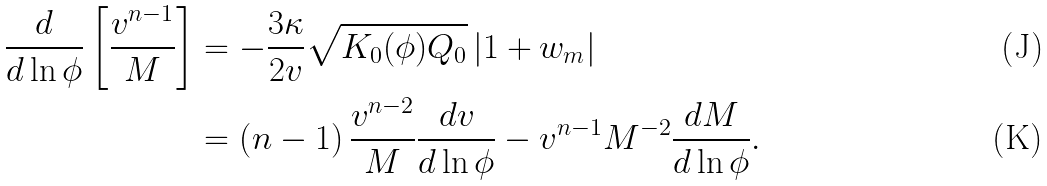<formula> <loc_0><loc_0><loc_500><loc_500>\frac { d } { d \ln \phi } \left [ \frac { v ^ { n - 1 } } { M } \right ] & = - \frac { 3 \kappa } { 2 v } \sqrt { K _ { 0 } ( \phi ) Q _ { 0 } } \left | 1 + w _ { m } \right | \\ & = \left ( n - 1 \right ) \frac { v ^ { n - 2 } } { M } \frac { d v } { d \ln \phi } - v ^ { n - 1 } M ^ { - 2 } \frac { d M } { d \ln \phi } .</formula> 